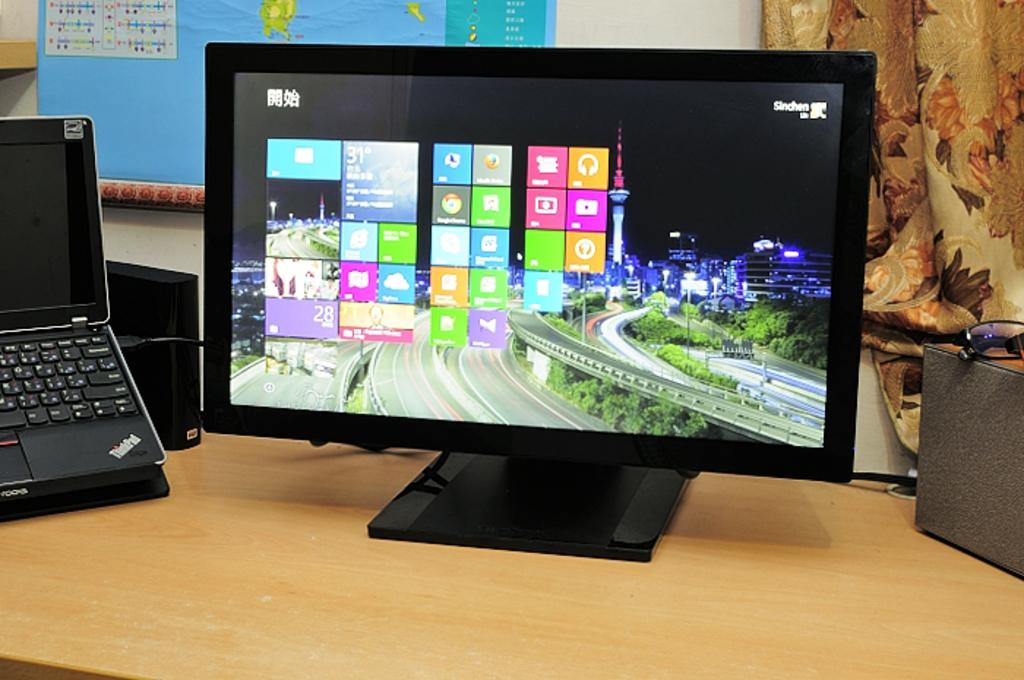<image>
Provide a brief description of the given image. A large computer monitor is next to an open ThinkPad laptop. 